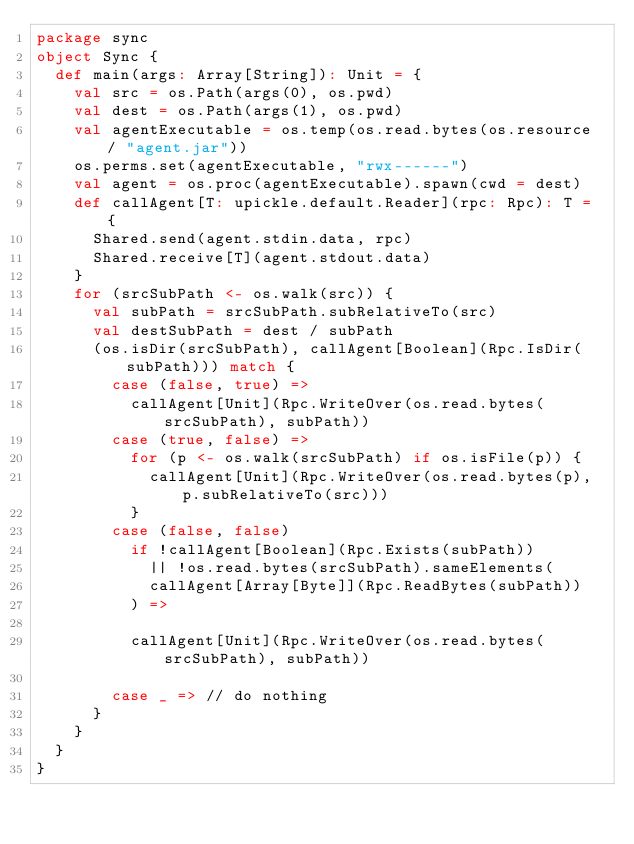<code> <loc_0><loc_0><loc_500><loc_500><_Scala_>package sync
object Sync {
  def main(args: Array[String]): Unit = {
    val src = os.Path(args(0), os.pwd)
    val dest = os.Path(args(1), os.pwd)
    val agentExecutable = os.temp(os.read.bytes(os.resource / "agent.jar"))
    os.perms.set(agentExecutable, "rwx------")
    val agent = os.proc(agentExecutable).spawn(cwd = dest)
    def callAgent[T: upickle.default.Reader](rpc: Rpc): T = {
      Shared.send(agent.stdin.data, rpc)
      Shared.receive[T](agent.stdout.data)
    }
    for (srcSubPath <- os.walk(src)) {
      val subPath = srcSubPath.subRelativeTo(src)
      val destSubPath = dest / subPath
      (os.isDir(srcSubPath), callAgent[Boolean](Rpc.IsDir(subPath))) match {
        case (false, true) =>
          callAgent[Unit](Rpc.WriteOver(os.read.bytes(srcSubPath), subPath))
        case (true, false) =>
          for (p <- os.walk(srcSubPath) if os.isFile(p)) {
            callAgent[Unit](Rpc.WriteOver(os.read.bytes(p), p.subRelativeTo(src)))
          }
        case (false, false)
          if !callAgent[Boolean](Rpc.Exists(subPath))
            || !os.read.bytes(srcSubPath).sameElements(
            callAgent[Array[Byte]](Rpc.ReadBytes(subPath))
          ) =>

          callAgent[Unit](Rpc.WriteOver(os.read.bytes(srcSubPath), subPath))

        case _ => // do nothing
      }
    }
  }
}</code> 